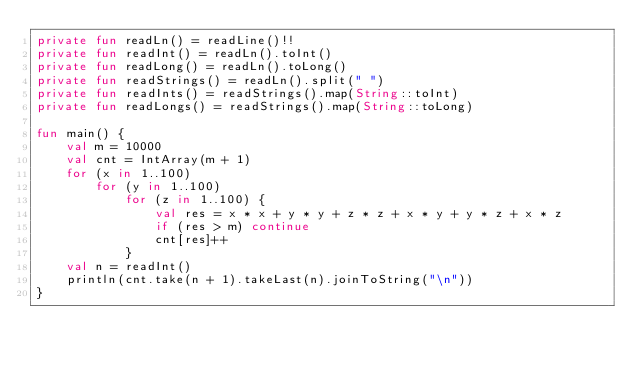<code> <loc_0><loc_0><loc_500><loc_500><_Kotlin_>private fun readLn() = readLine()!!
private fun readInt() = readLn().toInt()
private fun readLong() = readLn().toLong()
private fun readStrings() = readLn().split(" ")
private fun readInts() = readStrings().map(String::toInt)
private fun readLongs() = readStrings().map(String::toLong)

fun main() {
    val m = 10000
    val cnt = IntArray(m + 1)
    for (x in 1..100)
        for (y in 1..100)
            for (z in 1..100) {
                val res = x * x + y * y + z * z + x * y + y * z + x * z
                if (res > m) continue
                cnt[res]++
            }
    val n = readInt()
    println(cnt.take(n + 1).takeLast(n).joinToString("\n"))
}</code> 